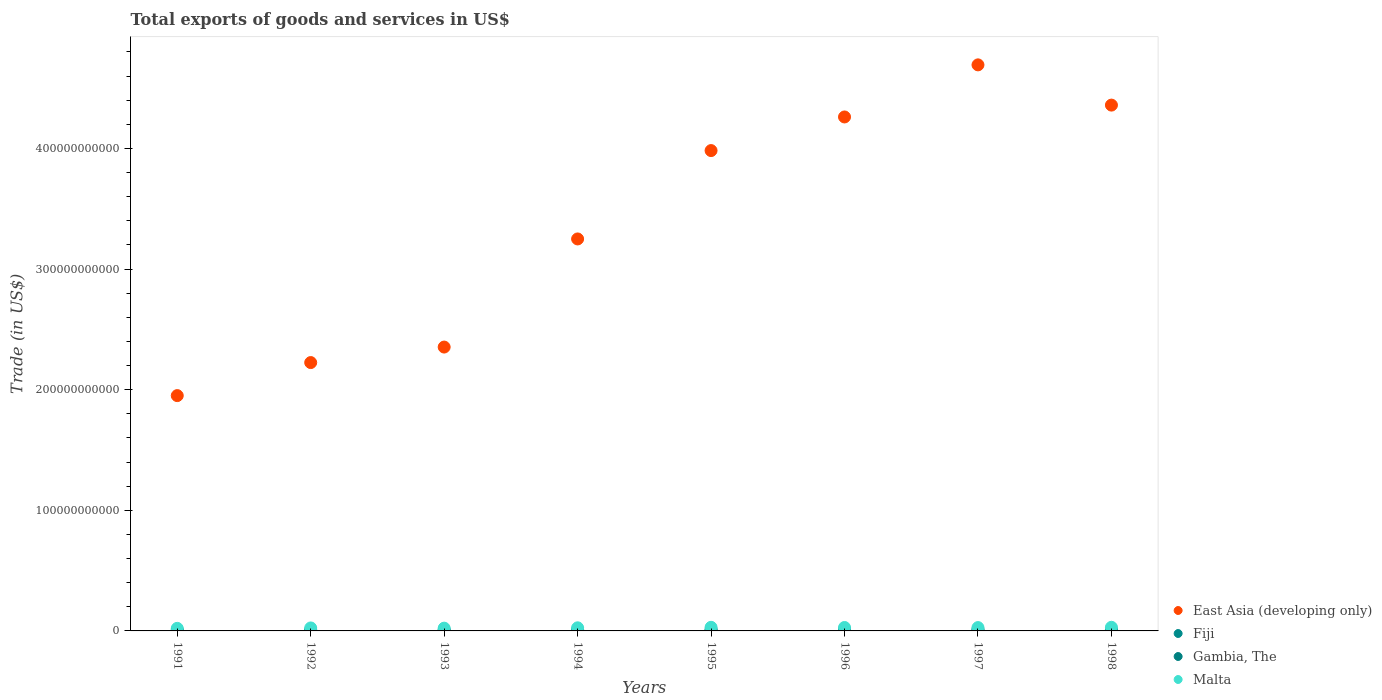How many different coloured dotlines are there?
Ensure brevity in your answer.  4. Is the number of dotlines equal to the number of legend labels?
Ensure brevity in your answer.  Yes. What is the total exports of goods and services in East Asia (developing only) in 1992?
Keep it short and to the point. 2.22e+11. Across all years, what is the maximum total exports of goods and services in Malta?
Offer a very short reply. 3.00e+09. Across all years, what is the minimum total exports of goods and services in Gambia, The?
Your answer should be very brief. 1.59e+08. In which year was the total exports of goods and services in East Asia (developing only) maximum?
Your answer should be compact. 1997. In which year was the total exports of goods and services in Fiji minimum?
Provide a succinct answer. 1991. What is the total total exports of goods and services in Fiji in the graph?
Your answer should be compact. 8.27e+09. What is the difference between the total exports of goods and services in East Asia (developing only) in 1994 and that in 1996?
Keep it short and to the point. -1.01e+11. What is the difference between the total exports of goods and services in Malta in 1998 and the total exports of goods and services in East Asia (developing only) in 1995?
Your answer should be compact. -3.95e+11. What is the average total exports of goods and services in Gambia, The per year?
Make the answer very short. 1.95e+08. In the year 1997, what is the difference between the total exports of goods and services in Fiji and total exports of goods and services in Gambia, The?
Ensure brevity in your answer.  1.09e+09. In how many years, is the total exports of goods and services in Fiji greater than 140000000000 US$?
Give a very brief answer. 0. What is the ratio of the total exports of goods and services in Malta in 1991 to that in 1995?
Give a very brief answer. 0.71. Is the difference between the total exports of goods and services in Fiji in 1993 and 1995 greater than the difference between the total exports of goods and services in Gambia, The in 1993 and 1995?
Your answer should be very brief. No. What is the difference between the highest and the second highest total exports of goods and services in Fiji?
Make the answer very short. 6.00e+07. What is the difference between the highest and the lowest total exports of goods and services in Gambia, The?
Your answer should be very brief. 6.00e+07. In how many years, is the total exports of goods and services in East Asia (developing only) greater than the average total exports of goods and services in East Asia (developing only) taken over all years?
Make the answer very short. 4. Is the sum of the total exports of goods and services in Gambia, The in 1993 and 1994 greater than the maximum total exports of goods and services in Fiji across all years?
Offer a terse response. No. Is it the case that in every year, the sum of the total exports of goods and services in Gambia, The and total exports of goods and services in Fiji  is greater than the sum of total exports of goods and services in East Asia (developing only) and total exports of goods and services in Malta?
Ensure brevity in your answer.  Yes. Is it the case that in every year, the sum of the total exports of goods and services in East Asia (developing only) and total exports of goods and services in Malta  is greater than the total exports of goods and services in Gambia, The?
Provide a succinct answer. Yes. Does the total exports of goods and services in East Asia (developing only) monotonically increase over the years?
Offer a very short reply. No. Is the total exports of goods and services in Gambia, The strictly less than the total exports of goods and services in Fiji over the years?
Offer a very short reply. Yes. How many dotlines are there?
Offer a very short reply. 4. What is the difference between two consecutive major ticks on the Y-axis?
Keep it short and to the point. 1.00e+11. Are the values on the major ticks of Y-axis written in scientific E-notation?
Keep it short and to the point. No. Does the graph contain any zero values?
Offer a terse response. No. Where does the legend appear in the graph?
Ensure brevity in your answer.  Bottom right. How many legend labels are there?
Offer a very short reply. 4. How are the legend labels stacked?
Offer a very short reply. Vertical. What is the title of the graph?
Your answer should be compact. Total exports of goods and services in US$. What is the label or title of the X-axis?
Provide a succinct answer. Years. What is the label or title of the Y-axis?
Ensure brevity in your answer.  Trade (in US$). What is the Trade (in US$) in East Asia (developing only) in 1991?
Your answer should be very brief. 1.95e+11. What is the Trade (in US$) in Fiji in 1991?
Ensure brevity in your answer.  7.93e+08. What is the Trade (in US$) in Gambia, The in 1991?
Keep it short and to the point. 2.03e+08. What is the Trade (in US$) of Malta in 1991?
Provide a short and direct response. 2.13e+09. What is the Trade (in US$) in East Asia (developing only) in 1992?
Provide a short and direct response. 2.22e+11. What is the Trade (in US$) in Fiji in 1992?
Your response must be concise. 7.95e+08. What is the Trade (in US$) of Gambia, The in 1992?
Your answer should be compact. 2.19e+08. What is the Trade (in US$) in Malta in 1992?
Provide a succinct answer. 2.47e+09. What is the Trade (in US$) in East Asia (developing only) in 1993?
Keep it short and to the point. 2.35e+11. What is the Trade (in US$) of Fiji in 1993?
Your answer should be very brief. 8.57e+08. What is the Trade (in US$) in Gambia, The in 1993?
Make the answer very short. 2.13e+08. What is the Trade (in US$) of Malta in 1993?
Your answer should be very brief. 2.30e+09. What is the Trade (in US$) in East Asia (developing only) in 1994?
Keep it short and to the point. 3.25e+11. What is the Trade (in US$) of Fiji in 1994?
Ensure brevity in your answer.  1.03e+09. What is the Trade (in US$) of Gambia, The in 1994?
Your response must be concise. 1.59e+08. What is the Trade (in US$) in Malta in 1994?
Offer a very short reply. 2.58e+09. What is the Trade (in US$) of East Asia (developing only) in 1995?
Your answer should be very brief. 3.98e+11. What is the Trade (in US$) in Fiji in 1995?
Give a very brief answer. 1.17e+09. What is the Trade (in US$) of Gambia, The in 1995?
Offer a terse response. 1.87e+08. What is the Trade (in US$) of Malta in 1995?
Your answer should be compact. 2.99e+09. What is the Trade (in US$) in East Asia (developing only) in 1996?
Provide a succinct answer. 4.26e+11. What is the Trade (in US$) of Fiji in 1996?
Your answer should be very brief. 1.34e+09. What is the Trade (in US$) of Gambia, The in 1996?
Ensure brevity in your answer.  1.85e+08. What is the Trade (in US$) in Malta in 1996?
Make the answer very short. 2.84e+09. What is the Trade (in US$) in East Asia (developing only) in 1997?
Your response must be concise. 4.69e+11. What is the Trade (in US$) in Fiji in 1997?
Give a very brief answer. 1.28e+09. What is the Trade (in US$) of Gambia, The in 1997?
Offer a very short reply. 1.84e+08. What is the Trade (in US$) of Malta in 1997?
Provide a short and direct response. 2.77e+09. What is the Trade (in US$) in East Asia (developing only) in 1998?
Ensure brevity in your answer.  4.36e+11. What is the Trade (in US$) in Fiji in 1998?
Your answer should be compact. 1.01e+09. What is the Trade (in US$) of Gambia, The in 1998?
Provide a short and direct response. 2.13e+08. What is the Trade (in US$) of Malta in 1998?
Offer a very short reply. 3.00e+09. Across all years, what is the maximum Trade (in US$) of East Asia (developing only)?
Your answer should be compact. 4.69e+11. Across all years, what is the maximum Trade (in US$) of Fiji?
Keep it short and to the point. 1.34e+09. Across all years, what is the maximum Trade (in US$) of Gambia, The?
Keep it short and to the point. 2.19e+08. Across all years, what is the maximum Trade (in US$) in Malta?
Make the answer very short. 3.00e+09. Across all years, what is the minimum Trade (in US$) of East Asia (developing only)?
Keep it short and to the point. 1.95e+11. Across all years, what is the minimum Trade (in US$) of Fiji?
Your answer should be very brief. 7.93e+08. Across all years, what is the minimum Trade (in US$) in Gambia, The?
Make the answer very short. 1.59e+08. Across all years, what is the minimum Trade (in US$) of Malta?
Your answer should be compact. 2.13e+09. What is the total Trade (in US$) in East Asia (developing only) in the graph?
Your answer should be very brief. 2.71e+12. What is the total Trade (in US$) in Fiji in the graph?
Your answer should be compact. 8.27e+09. What is the total Trade (in US$) in Gambia, The in the graph?
Your response must be concise. 1.56e+09. What is the total Trade (in US$) of Malta in the graph?
Offer a terse response. 2.11e+1. What is the difference between the Trade (in US$) of East Asia (developing only) in 1991 and that in 1992?
Make the answer very short. -2.74e+1. What is the difference between the Trade (in US$) in Fiji in 1991 and that in 1992?
Your answer should be very brief. -2.18e+06. What is the difference between the Trade (in US$) in Gambia, The in 1991 and that in 1992?
Offer a very short reply. -1.53e+07. What is the difference between the Trade (in US$) in Malta in 1991 and that in 1992?
Your answer should be compact. -3.43e+08. What is the difference between the Trade (in US$) in East Asia (developing only) in 1991 and that in 1993?
Ensure brevity in your answer.  -4.02e+1. What is the difference between the Trade (in US$) in Fiji in 1991 and that in 1993?
Keep it short and to the point. -6.35e+07. What is the difference between the Trade (in US$) of Gambia, The in 1991 and that in 1993?
Make the answer very short. -9.64e+06. What is the difference between the Trade (in US$) in Malta in 1991 and that in 1993?
Ensure brevity in your answer.  -1.70e+08. What is the difference between the Trade (in US$) in East Asia (developing only) in 1991 and that in 1994?
Your response must be concise. -1.30e+11. What is the difference between the Trade (in US$) of Fiji in 1991 and that in 1994?
Your response must be concise. -2.37e+08. What is the difference between the Trade (in US$) of Gambia, The in 1991 and that in 1994?
Keep it short and to the point. 4.47e+07. What is the difference between the Trade (in US$) in Malta in 1991 and that in 1994?
Offer a terse response. -4.50e+08. What is the difference between the Trade (in US$) in East Asia (developing only) in 1991 and that in 1995?
Your answer should be compact. -2.03e+11. What is the difference between the Trade (in US$) in Fiji in 1991 and that in 1995?
Provide a succinct answer. -3.75e+08. What is the difference between the Trade (in US$) in Gambia, The in 1991 and that in 1995?
Provide a succinct answer. 1.63e+07. What is the difference between the Trade (in US$) of Malta in 1991 and that in 1995?
Make the answer very short. -8.63e+08. What is the difference between the Trade (in US$) of East Asia (developing only) in 1991 and that in 1996?
Provide a short and direct response. -2.31e+11. What is the difference between the Trade (in US$) of Fiji in 1991 and that in 1996?
Offer a terse response. -5.45e+08. What is the difference between the Trade (in US$) of Gambia, The in 1991 and that in 1996?
Your answer should be very brief. 1.83e+07. What is the difference between the Trade (in US$) in Malta in 1991 and that in 1996?
Provide a succinct answer. -7.15e+08. What is the difference between the Trade (in US$) of East Asia (developing only) in 1991 and that in 1997?
Your answer should be very brief. -2.74e+11. What is the difference between the Trade (in US$) of Fiji in 1991 and that in 1997?
Keep it short and to the point. -4.85e+08. What is the difference between the Trade (in US$) of Gambia, The in 1991 and that in 1997?
Give a very brief answer. 1.89e+07. What is the difference between the Trade (in US$) of Malta in 1991 and that in 1997?
Keep it short and to the point. -6.44e+08. What is the difference between the Trade (in US$) of East Asia (developing only) in 1991 and that in 1998?
Your response must be concise. -2.41e+11. What is the difference between the Trade (in US$) in Fiji in 1991 and that in 1998?
Offer a terse response. -2.14e+08. What is the difference between the Trade (in US$) in Gambia, The in 1991 and that in 1998?
Make the answer very short. -9.42e+06. What is the difference between the Trade (in US$) of Malta in 1991 and that in 1998?
Ensure brevity in your answer.  -8.77e+08. What is the difference between the Trade (in US$) in East Asia (developing only) in 1992 and that in 1993?
Ensure brevity in your answer.  -1.29e+1. What is the difference between the Trade (in US$) of Fiji in 1992 and that in 1993?
Provide a short and direct response. -6.13e+07. What is the difference between the Trade (in US$) of Gambia, The in 1992 and that in 1993?
Ensure brevity in your answer.  5.65e+06. What is the difference between the Trade (in US$) of Malta in 1992 and that in 1993?
Your answer should be compact. 1.73e+08. What is the difference between the Trade (in US$) in East Asia (developing only) in 1992 and that in 1994?
Ensure brevity in your answer.  -1.02e+11. What is the difference between the Trade (in US$) in Fiji in 1992 and that in 1994?
Your answer should be compact. -2.35e+08. What is the difference between the Trade (in US$) of Gambia, The in 1992 and that in 1994?
Provide a succinct answer. 6.00e+07. What is the difference between the Trade (in US$) of Malta in 1992 and that in 1994?
Your answer should be compact. -1.07e+08. What is the difference between the Trade (in US$) of East Asia (developing only) in 1992 and that in 1995?
Your response must be concise. -1.76e+11. What is the difference between the Trade (in US$) of Fiji in 1992 and that in 1995?
Your answer should be very brief. -3.73e+08. What is the difference between the Trade (in US$) of Gambia, The in 1992 and that in 1995?
Keep it short and to the point. 3.16e+07. What is the difference between the Trade (in US$) of Malta in 1992 and that in 1995?
Keep it short and to the point. -5.20e+08. What is the difference between the Trade (in US$) in East Asia (developing only) in 1992 and that in 1996?
Ensure brevity in your answer.  -2.04e+11. What is the difference between the Trade (in US$) of Fiji in 1992 and that in 1996?
Provide a short and direct response. -5.43e+08. What is the difference between the Trade (in US$) in Gambia, The in 1992 and that in 1996?
Give a very brief answer. 3.36e+07. What is the difference between the Trade (in US$) of Malta in 1992 and that in 1996?
Give a very brief answer. -3.72e+08. What is the difference between the Trade (in US$) in East Asia (developing only) in 1992 and that in 1997?
Offer a very short reply. -2.47e+11. What is the difference between the Trade (in US$) in Fiji in 1992 and that in 1997?
Your answer should be very brief. -4.83e+08. What is the difference between the Trade (in US$) in Gambia, The in 1992 and that in 1997?
Offer a very short reply. 3.42e+07. What is the difference between the Trade (in US$) of Malta in 1992 and that in 1997?
Keep it short and to the point. -3.01e+08. What is the difference between the Trade (in US$) in East Asia (developing only) in 1992 and that in 1998?
Your response must be concise. -2.13e+11. What is the difference between the Trade (in US$) in Fiji in 1992 and that in 1998?
Provide a short and direct response. -2.12e+08. What is the difference between the Trade (in US$) of Gambia, The in 1992 and that in 1998?
Offer a terse response. 5.87e+06. What is the difference between the Trade (in US$) of Malta in 1992 and that in 1998?
Provide a short and direct response. -5.34e+08. What is the difference between the Trade (in US$) in East Asia (developing only) in 1993 and that in 1994?
Offer a very short reply. -8.96e+1. What is the difference between the Trade (in US$) of Fiji in 1993 and that in 1994?
Ensure brevity in your answer.  -1.73e+08. What is the difference between the Trade (in US$) in Gambia, The in 1993 and that in 1994?
Your answer should be very brief. 5.43e+07. What is the difference between the Trade (in US$) of Malta in 1993 and that in 1994?
Provide a succinct answer. -2.80e+08. What is the difference between the Trade (in US$) in East Asia (developing only) in 1993 and that in 1995?
Keep it short and to the point. -1.63e+11. What is the difference between the Trade (in US$) of Fiji in 1993 and that in 1995?
Provide a short and direct response. -3.12e+08. What is the difference between the Trade (in US$) of Gambia, The in 1993 and that in 1995?
Offer a very short reply. 2.60e+07. What is the difference between the Trade (in US$) in Malta in 1993 and that in 1995?
Your answer should be very brief. -6.93e+08. What is the difference between the Trade (in US$) in East Asia (developing only) in 1993 and that in 1996?
Provide a succinct answer. -1.91e+11. What is the difference between the Trade (in US$) in Fiji in 1993 and that in 1996?
Ensure brevity in your answer.  -4.82e+08. What is the difference between the Trade (in US$) in Gambia, The in 1993 and that in 1996?
Give a very brief answer. 2.80e+07. What is the difference between the Trade (in US$) of Malta in 1993 and that in 1996?
Offer a terse response. -5.45e+08. What is the difference between the Trade (in US$) of East Asia (developing only) in 1993 and that in 1997?
Your answer should be very brief. -2.34e+11. What is the difference between the Trade (in US$) of Fiji in 1993 and that in 1997?
Make the answer very short. -4.22e+08. What is the difference between the Trade (in US$) in Gambia, The in 1993 and that in 1997?
Offer a terse response. 2.86e+07. What is the difference between the Trade (in US$) of Malta in 1993 and that in 1997?
Your answer should be compact. -4.74e+08. What is the difference between the Trade (in US$) in East Asia (developing only) in 1993 and that in 1998?
Provide a succinct answer. -2.01e+11. What is the difference between the Trade (in US$) in Fiji in 1993 and that in 1998?
Offer a very short reply. -1.51e+08. What is the difference between the Trade (in US$) in Gambia, The in 1993 and that in 1998?
Give a very brief answer. 2.23e+05. What is the difference between the Trade (in US$) of Malta in 1993 and that in 1998?
Provide a succinct answer. -7.07e+08. What is the difference between the Trade (in US$) of East Asia (developing only) in 1994 and that in 1995?
Your answer should be compact. -7.33e+1. What is the difference between the Trade (in US$) of Fiji in 1994 and that in 1995?
Give a very brief answer. -1.38e+08. What is the difference between the Trade (in US$) in Gambia, The in 1994 and that in 1995?
Offer a very short reply. -2.83e+07. What is the difference between the Trade (in US$) of Malta in 1994 and that in 1995?
Your answer should be compact. -4.13e+08. What is the difference between the Trade (in US$) of East Asia (developing only) in 1994 and that in 1996?
Offer a very short reply. -1.01e+11. What is the difference between the Trade (in US$) of Fiji in 1994 and that in 1996?
Make the answer very short. -3.08e+08. What is the difference between the Trade (in US$) of Gambia, The in 1994 and that in 1996?
Provide a short and direct response. -2.64e+07. What is the difference between the Trade (in US$) of Malta in 1994 and that in 1996?
Your response must be concise. -2.65e+08. What is the difference between the Trade (in US$) in East Asia (developing only) in 1994 and that in 1997?
Your response must be concise. -1.44e+11. What is the difference between the Trade (in US$) in Fiji in 1994 and that in 1997?
Make the answer very short. -2.48e+08. What is the difference between the Trade (in US$) in Gambia, The in 1994 and that in 1997?
Make the answer very short. -2.57e+07. What is the difference between the Trade (in US$) of Malta in 1994 and that in 1997?
Ensure brevity in your answer.  -1.94e+08. What is the difference between the Trade (in US$) of East Asia (developing only) in 1994 and that in 1998?
Provide a short and direct response. -1.11e+11. What is the difference between the Trade (in US$) in Fiji in 1994 and that in 1998?
Make the answer very short. 2.24e+07. What is the difference between the Trade (in US$) in Gambia, The in 1994 and that in 1998?
Make the answer very short. -5.41e+07. What is the difference between the Trade (in US$) of Malta in 1994 and that in 1998?
Offer a very short reply. -4.27e+08. What is the difference between the Trade (in US$) in East Asia (developing only) in 1995 and that in 1996?
Give a very brief answer. -2.79e+1. What is the difference between the Trade (in US$) of Fiji in 1995 and that in 1996?
Provide a succinct answer. -1.70e+08. What is the difference between the Trade (in US$) in Gambia, The in 1995 and that in 1996?
Your answer should be very brief. 1.97e+06. What is the difference between the Trade (in US$) in Malta in 1995 and that in 1996?
Your answer should be very brief. 1.48e+08. What is the difference between the Trade (in US$) in East Asia (developing only) in 1995 and that in 1997?
Offer a terse response. -7.11e+1. What is the difference between the Trade (in US$) in Fiji in 1995 and that in 1997?
Offer a very short reply. -1.10e+08. What is the difference between the Trade (in US$) of Gambia, The in 1995 and that in 1997?
Your answer should be very brief. 2.59e+06. What is the difference between the Trade (in US$) in Malta in 1995 and that in 1997?
Make the answer very short. 2.19e+08. What is the difference between the Trade (in US$) in East Asia (developing only) in 1995 and that in 1998?
Keep it short and to the point. -3.77e+1. What is the difference between the Trade (in US$) of Fiji in 1995 and that in 1998?
Make the answer very short. 1.61e+08. What is the difference between the Trade (in US$) in Gambia, The in 1995 and that in 1998?
Your answer should be very brief. -2.58e+07. What is the difference between the Trade (in US$) of Malta in 1995 and that in 1998?
Your answer should be very brief. -1.41e+07. What is the difference between the Trade (in US$) of East Asia (developing only) in 1996 and that in 1997?
Make the answer very short. -4.32e+1. What is the difference between the Trade (in US$) of Fiji in 1996 and that in 1997?
Provide a short and direct response. 6.00e+07. What is the difference between the Trade (in US$) of Gambia, The in 1996 and that in 1997?
Keep it short and to the point. 6.14e+05. What is the difference between the Trade (in US$) in Malta in 1996 and that in 1997?
Make the answer very short. 7.13e+07. What is the difference between the Trade (in US$) in East Asia (developing only) in 1996 and that in 1998?
Keep it short and to the point. -9.82e+09. What is the difference between the Trade (in US$) of Fiji in 1996 and that in 1998?
Your answer should be compact. 3.31e+08. What is the difference between the Trade (in US$) of Gambia, The in 1996 and that in 1998?
Your answer should be compact. -2.77e+07. What is the difference between the Trade (in US$) of Malta in 1996 and that in 1998?
Your answer should be compact. -1.62e+08. What is the difference between the Trade (in US$) in East Asia (developing only) in 1997 and that in 1998?
Your answer should be compact. 3.34e+1. What is the difference between the Trade (in US$) in Fiji in 1997 and that in 1998?
Make the answer very short. 2.71e+08. What is the difference between the Trade (in US$) of Gambia, The in 1997 and that in 1998?
Provide a short and direct response. -2.83e+07. What is the difference between the Trade (in US$) of Malta in 1997 and that in 1998?
Offer a terse response. -2.33e+08. What is the difference between the Trade (in US$) in East Asia (developing only) in 1991 and the Trade (in US$) in Fiji in 1992?
Offer a very short reply. 1.94e+11. What is the difference between the Trade (in US$) of East Asia (developing only) in 1991 and the Trade (in US$) of Gambia, The in 1992?
Your response must be concise. 1.95e+11. What is the difference between the Trade (in US$) of East Asia (developing only) in 1991 and the Trade (in US$) of Malta in 1992?
Your answer should be very brief. 1.93e+11. What is the difference between the Trade (in US$) in Fiji in 1991 and the Trade (in US$) in Gambia, The in 1992?
Keep it short and to the point. 5.75e+08. What is the difference between the Trade (in US$) in Fiji in 1991 and the Trade (in US$) in Malta in 1992?
Keep it short and to the point. -1.68e+09. What is the difference between the Trade (in US$) in Gambia, The in 1991 and the Trade (in US$) in Malta in 1992?
Make the answer very short. -2.27e+09. What is the difference between the Trade (in US$) in East Asia (developing only) in 1991 and the Trade (in US$) in Fiji in 1993?
Make the answer very short. 1.94e+11. What is the difference between the Trade (in US$) of East Asia (developing only) in 1991 and the Trade (in US$) of Gambia, The in 1993?
Your answer should be compact. 1.95e+11. What is the difference between the Trade (in US$) in East Asia (developing only) in 1991 and the Trade (in US$) in Malta in 1993?
Your response must be concise. 1.93e+11. What is the difference between the Trade (in US$) in Fiji in 1991 and the Trade (in US$) in Gambia, The in 1993?
Your answer should be very brief. 5.80e+08. What is the difference between the Trade (in US$) in Fiji in 1991 and the Trade (in US$) in Malta in 1993?
Your response must be concise. -1.50e+09. What is the difference between the Trade (in US$) of Gambia, The in 1991 and the Trade (in US$) of Malta in 1993?
Make the answer very short. -2.09e+09. What is the difference between the Trade (in US$) of East Asia (developing only) in 1991 and the Trade (in US$) of Fiji in 1994?
Make the answer very short. 1.94e+11. What is the difference between the Trade (in US$) of East Asia (developing only) in 1991 and the Trade (in US$) of Gambia, The in 1994?
Make the answer very short. 1.95e+11. What is the difference between the Trade (in US$) in East Asia (developing only) in 1991 and the Trade (in US$) in Malta in 1994?
Ensure brevity in your answer.  1.92e+11. What is the difference between the Trade (in US$) in Fiji in 1991 and the Trade (in US$) in Gambia, The in 1994?
Your answer should be compact. 6.35e+08. What is the difference between the Trade (in US$) in Fiji in 1991 and the Trade (in US$) in Malta in 1994?
Provide a succinct answer. -1.78e+09. What is the difference between the Trade (in US$) in Gambia, The in 1991 and the Trade (in US$) in Malta in 1994?
Provide a short and direct response. -2.37e+09. What is the difference between the Trade (in US$) in East Asia (developing only) in 1991 and the Trade (in US$) in Fiji in 1995?
Make the answer very short. 1.94e+11. What is the difference between the Trade (in US$) of East Asia (developing only) in 1991 and the Trade (in US$) of Gambia, The in 1995?
Provide a succinct answer. 1.95e+11. What is the difference between the Trade (in US$) of East Asia (developing only) in 1991 and the Trade (in US$) of Malta in 1995?
Your answer should be very brief. 1.92e+11. What is the difference between the Trade (in US$) in Fiji in 1991 and the Trade (in US$) in Gambia, The in 1995?
Keep it short and to the point. 6.06e+08. What is the difference between the Trade (in US$) of Fiji in 1991 and the Trade (in US$) of Malta in 1995?
Make the answer very short. -2.20e+09. What is the difference between the Trade (in US$) in Gambia, The in 1991 and the Trade (in US$) in Malta in 1995?
Provide a short and direct response. -2.79e+09. What is the difference between the Trade (in US$) in East Asia (developing only) in 1991 and the Trade (in US$) in Fiji in 1996?
Offer a very short reply. 1.94e+11. What is the difference between the Trade (in US$) in East Asia (developing only) in 1991 and the Trade (in US$) in Gambia, The in 1996?
Make the answer very short. 1.95e+11. What is the difference between the Trade (in US$) of East Asia (developing only) in 1991 and the Trade (in US$) of Malta in 1996?
Provide a short and direct response. 1.92e+11. What is the difference between the Trade (in US$) of Fiji in 1991 and the Trade (in US$) of Gambia, The in 1996?
Offer a very short reply. 6.08e+08. What is the difference between the Trade (in US$) of Fiji in 1991 and the Trade (in US$) of Malta in 1996?
Offer a terse response. -2.05e+09. What is the difference between the Trade (in US$) of Gambia, The in 1991 and the Trade (in US$) of Malta in 1996?
Offer a terse response. -2.64e+09. What is the difference between the Trade (in US$) in East Asia (developing only) in 1991 and the Trade (in US$) in Fiji in 1997?
Ensure brevity in your answer.  1.94e+11. What is the difference between the Trade (in US$) in East Asia (developing only) in 1991 and the Trade (in US$) in Gambia, The in 1997?
Your answer should be compact. 1.95e+11. What is the difference between the Trade (in US$) in East Asia (developing only) in 1991 and the Trade (in US$) in Malta in 1997?
Offer a terse response. 1.92e+11. What is the difference between the Trade (in US$) in Fiji in 1991 and the Trade (in US$) in Gambia, The in 1997?
Provide a short and direct response. 6.09e+08. What is the difference between the Trade (in US$) in Fiji in 1991 and the Trade (in US$) in Malta in 1997?
Offer a very short reply. -1.98e+09. What is the difference between the Trade (in US$) in Gambia, The in 1991 and the Trade (in US$) in Malta in 1997?
Offer a very short reply. -2.57e+09. What is the difference between the Trade (in US$) of East Asia (developing only) in 1991 and the Trade (in US$) of Fiji in 1998?
Provide a short and direct response. 1.94e+11. What is the difference between the Trade (in US$) in East Asia (developing only) in 1991 and the Trade (in US$) in Gambia, The in 1998?
Offer a very short reply. 1.95e+11. What is the difference between the Trade (in US$) of East Asia (developing only) in 1991 and the Trade (in US$) of Malta in 1998?
Your answer should be compact. 1.92e+11. What is the difference between the Trade (in US$) in Fiji in 1991 and the Trade (in US$) in Gambia, The in 1998?
Ensure brevity in your answer.  5.80e+08. What is the difference between the Trade (in US$) of Fiji in 1991 and the Trade (in US$) of Malta in 1998?
Give a very brief answer. -2.21e+09. What is the difference between the Trade (in US$) of Gambia, The in 1991 and the Trade (in US$) of Malta in 1998?
Offer a terse response. -2.80e+09. What is the difference between the Trade (in US$) of East Asia (developing only) in 1992 and the Trade (in US$) of Fiji in 1993?
Your answer should be compact. 2.22e+11. What is the difference between the Trade (in US$) of East Asia (developing only) in 1992 and the Trade (in US$) of Gambia, The in 1993?
Provide a short and direct response. 2.22e+11. What is the difference between the Trade (in US$) in East Asia (developing only) in 1992 and the Trade (in US$) in Malta in 1993?
Make the answer very short. 2.20e+11. What is the difference between the Trade (in US$) in Fiji in 1992 and the Trade (in US$) in Gambia, The in 1993?
Offer a very short reply. 5.82e+08. What is the difference between the Trade (in US$) of Fiji in 1992 and the Trade (in US$) of Malta in 1993?
Give a very brief answer. -1.50e+09. What is the difference between the Trade (in US$) in Gambia, The in 1992 and the Trade (in US$) in Malta in 1993?
Ensure brevity in your answer.  -2.08e+09. What is the difference between the Trade (in US$) of East Asia (developing only) in 1992 and the Trade (in US$) of Fiji in 1994?
Give a very brief answer. 2.21e+11. What is the difference between the Trade (in US$) of East Asia (developing only) in 1992 and the Trade (in US$) of Gambia, The in 1994?
Offer a very short reply. 2.22e+11. What is the difference between the Trade (in US$) in East Asia (developing only) in 1992 and the Trade (in US$) in Malta in 1994?
Provide a succinct answer. 2.20e+11. What is the difference between the Trade (in US$) of Fiji in 1992 and the Trade (in US$) of Gambia, The in 1994?
Provide a short and direct response. 6.37e+08. What is the difference between the Trade (in US$) of Fiji in 1992 and the Trade (in US$) of Malta in 1994?
Your answer should be very brief. -1.78e+09. What is the difference between the Trade (in US$) in Gambia, The in 1992 and the Trade (in US$) in Malta in 1994?
Your answer should be compact. -2.36e+09. What is the difference between the Trade (in US$) of East Asia (developing only) in 1992 and the Trade (in US$) of Fiji in 1995?
Offer a very short reply. 2.21e+11. What is the difference between the Trade (in US$) in East Asia (developing only) in 1992 and the Trade (in US$) in Gambia, The in 1995?
Make the answer very short. 2.22e+11. What is the difference between the Trade (in US$) in East Asia (developing only) in 1992 and the Trade (in US$) in Malta in 1995?
Provide a short and direct response. 2.19e+11. What is the difference between the Trade (in US$) of Fiji in 1992 and the Trade (in US$) of Gambia, The in 1995?
Your answer should be compact. 6.08e+08. What is the difference between the Trade (in US$) of Fiji in 1992 and the Trade (in US$) of Malta in 1995?
Ensure brevity in your answer.  -2.20e+09. What is the difference between the Trade (in US$) in Gambia, The in 1992 and the Trade (in US$) in Malta in 1995?
Your answer should be very brief. -2.77e+09. What is the difference between the Trade (in US$) in East Asia (developing only) in 1992 and the Trade (in US$) in Fiji in 1996?
Offer a very short reply. 2.21e+11. What is the difference between the Trade (in US$) in East Asia (developing only) in 1992 and the Trade (in US$) in Gambia, The in 1996?
Your answer should be compact. 2.22e+11. What is the difference between the Trade (in US$) in East Asia (developing only) in 1992 and the Trade (in US$) in Malta in 1996?
Provide a succinct answer. 2.20e+11. What is the difference between the Trade (in US$) in Fiji in 1992 and the Trade (in US$) in Gambia, The in 1996?
Provide a succinct answer. 6.10e+08. What is the difference between the Trade (in US$) in Fiji in 1992 and the Trade (in US$) in Malta in 1996?
Provide a succinct answer. -2.05e+09. What is the difference between the Trade (in US$) in Gambia, The in 1992 and the Trade (in US$) in Malta in 1996?
Provide a short and direct response. -2.62e+09. What is the difference between the Trade (in US$) in East Asia (developing only) in 1992 and the Trade (in US$) in Fiji in 1997?
Offer a very short reply. 2.21e+11. What is the difference between the Trade (in US$) of East Asia (developing only) in 1992 and the Trade (in US$) of Gambia, The in 1997?
Offer a terse response. 2.22e+11. What is the difference between the Trade (in US$) in East Asia (developing only) in 1992 and the Trade (in US$) in Malta in 1997?
Provide a short and direct response. 2.20e+11. What is the difference between the Trade (in US$) in Fiji in 1992 and the Trade (in US$) in Gambia, The in 1997?
Ensure brevity in your answer.  6.11e+08. What is the difference between the Trade (in US$) of Fiji in 1992 and the Trade (in US$) of Malta in 1997?
Ensure brevity in your answer.  -1.98e+09. What is the difference between the Trade (in US$) in Gambia, The in 1992 and the Trade (in US$) in Malta in 1997?
Your answer should be very brief. -2.55e+09. What is the difference between the Trade (in US$) in East Asia (developing only) in 1992 and the Trade (in US$) in Fiji in 1998?
Ensure brevity in your answer.  2.21e+11. What is the difference between the Trade (in US$) in East Asia (developing only) in 1992 and the Trade (in US$) in Gambia, The in 1998?
Your response must be concise. 2.22e+11. What is the difference between the Trade (in US$) in East Asia (developing only) in 1992 and the Trade (in US$) in Malta in 1998?
Offer a terse response. 2.19e+11. What is the difference between the Trade (in US$) of Fiji in 1992 and the Trade (in US$) of Gambia, The in 1998?
Your answer should be very brief. 5.83e+08. What is the difference between the Trade (in US$) of Fiji in 1992 and the Trade (in US$) of Malta in 1998?
Make the answer very short. -2.21e+09. What is the difference between the Trade (in US$) in Gambia, The in 1992 and the Trade (in US$) in Malta in 1998?
Offer a very short reply. -2.79e+09. What is the difference between the Trade (in US$) of East Asia (developing only) in 1993 and the Trade (in US$) of Fiji in 1994?
Offer a very short reply. 2.34e+11. What is the difference between the Trade (in US$) in East Asia (developing only) in 1993 and the Trade (in US$) in Gambia, The in 1994?
Your response must be concise. 2.35e+11. What is the difference between the Trade (in US$) of East Asia (developing only) in 1993 and the Trade (in US$) of Malta in 1994?
Your answer should be compact. 2.33e+11. What is the difference between the Trade (in US$) of Fiji in 1993 and the Trade (in US$) of Gambia, The in 1994?
Provide a succinct answer. 6.98e+08. What is the difference between the Trade (in US$) of Fiji in 1993 and the Trade (in US$) of Malta in 1994?
Offer a terse response. -1.72e+09. What is the difference between the Trade (in US$) of Gambia, The in 1993 and the Trade (in US$) of Malta in 1994?
Your answer should be very brief. -2.36e+09. What is the difference between the Trade (in US$) in East Asia (developing only) in 1993 and the Trade (in US$) in Fiji in 1995?
Ensure brevity in your answer.  2.34e+11. What is the difference between the Trade (in US$) in East Asia (developing only) in 1993 and the Trade (in US$) in Gambia, The in 1995?
Provide a succinct answer. 2.35e+11. What is the difference between the Trade (in US$) of East Asia (developing only) in 1993 and the Trade (in US$) of Malta in 1995?
Give a very brief answer. 2.32e+11. What is the difference between the Trade (in US$) in Fiji in 1993 and the Trade (in US$) in Gambia, The in 1995?
Your answer should be very brief. 6.70e+08. What is the difference between the Trade (in US$) in Fiji in 1993 and the Trade (in US$) in Malta in 1995?
Offer a terse response. -2.13e+09. What is the difference between the Trade (in US$) in Gambia, The in 1993 and the Trade (in US$) in Malta in 1995?
Keep it short and to the point. -2.78e+09. What is the difference between the Trade (in US$) of East Asia (developing only) in 1993 and the Trade (in US$) of Fiji in 1996?
Keep it short and to the point. 2.34e+11. What is the difference between the Trade (in US$) of East Asia (developing only) in 1993 and the Trade (in US$) of Gambia, The in 1996?
Keep it short and to the point. 2.35e+11. What is the difference between the Trade (in US$) in East Asia (developing only) in 1993 and the Trade (in US$) in Malta in 1996?
Your answer should be very brief. 2.32e+11. What is the difference between the Trade (in US$) in Fiji in 1993 and the Trade (in US$) in Gambia, The in 1996?
Your answer should be compact. 6.72e+08. What is the difference between the Trade (in US$) in Fiji in 1993 and the Trade (in US$) in Malta in 1996?
Offer a terse response. -1.99e+09. What is the difference between the Trade (in US$) of Gambia, The in 1993 and the Trade (in US$) of Malta in 1996?
Keep it short and to the point. -2.63e+09. What is the difference between the Trade (in US$) in East Asia (developing only) in 1993 and the Trade (in US$) in Fiji in 1997?
Provide a succinct answer. 2.34e+11. What is the difference between the Trade (in US$) in East Asia (developing only) in 1993 and the Trade (in US$) in Gambia, The in 1997?
Give a very brief answer. 2.35e+11. What is the difference between the Trade (in US$) in East Asia (developing only) in 1993 and the Trade (in US$) in Malta in 1997?
Provide a succinct answer. 2.33e+11. What is the difference between the Trade (in US$) in Fiji in 1993 and the Trade (in US$) in Gambia, The in 1997?
Your answer should be compact. 6.72e+08. What is the difference between the Trade (in US$) of Fiji in 1993 and the Trade (in US$) of Malta in 1997?
Offer a very short reply. -1.91e+09. What is the difference between the Trade (in US$) in Gambia, The in 1993 and the Trade (in US$) in Malta in 1997?
Your response must be concise. -2.56e+09. What is the difference between the Trade (in US$) in East Asia (developing only) in 1993 and the Trade (in US$) in Fiji in 1998?
Your answer should be compact. 2.34e+11. What is the difference between the Trade (in US$) of East Asia (developing only) in 1993 and the Trade (in US$) of Gambia, The in 1998?
Provide a short and direct response. 2.35e+11. What is the difference between the Trade (in US$) of East Asia (developing only) in 1993 and the Trade (in US$) of Malta in 1998?
Provide a short and direct response. 2.32e+11. What is the difference between the Trade (in US$) of Fiji in 1993 and the Trade (in US$) of Gambia, The in 1998?
Offer a very short reply. 6.44e+08. What is the difference between the Trade (in US$) in Fiji in 1993 and the Trade (in US$) in Malta in 1998?
Ensure brevity in your answer.  -2.15e+09. What is the difference between the Trade (in US$) in Gambia, The in 1993 and the Trade (in US$) in Malta in 1998?
Your response must be concise. -2.79e+09. What is the difference between the Trade (in US$) of East Asia (developing only) in 1994 and the Trade (in US$) of Fiji in 1995?
Offer a terse response. 3.24e+11. What is the difference between the Trade (in US$) of East Asia (developing only) in 1994 and the Trade (in US$) of Gambia, The in 1995?
Keep it short and to the point. 3.25e+11. What is the difference between the Trade (in US$) in East Asia (developing only) in 1994 and the Trade (in US$) in Malta in 1995?
Offer a very short reply. 3.22e+11. What is the difference between the Trade (in US$) in Fiji in 1994 and the Trade (in US$) in Gambia, The in 1995?
Make the answer very short. 8.43e+08. What is the difference between the Trade (in US$) of Fiji in 1994 and the Trade (in US$) of Malta in 1995?
Provide a short and direct response. -1.96e+09. What is the difference between the Trade (in US$) in Gambia, The in 1994 and the Trade (in US$) in Malta in 1995?
Make the answer very short. -2.83e+09. What is the difference between the Trade (in US$) in East Asia (developing only) in 1994 and the Trade (in US$) in Fiji in 1996?
Make the answer very short. 3.24e+11. What is the difference between the Trade (in US$) of East Asia (developing only) in 1994 and the Trade (in US$) of Gambia, The in 1996?
Your response must be concise. 3.25e+11. What is the difference between the Trade (in US$) in East Asia (developing only) in 1994 and the Trade (in US$) in Malta in 1996?
Provide a short and direct response. 3.22e+11. What is the difference between the Trade (in US$) in Fiji in 1994 and the Trade (in US$) in Gambia, The in 1996?
Provide a short and direct response. 8.45e+08. What is the difference between the Trade (in US$) of Fiji in 1994 and the Trade (in US$) of Malta in 1996?
Provide a succinct answer. -1.81e+09. What is the difference between the Trade (in US$) in Gambia, The in 1994 and the Trade (in US$) in Malta in 1996?
Provide a succinct answer. -2.68e+09. What is the difference between the Trade (in US$) of East Asia (developing only) in 1994 and the Trade (in US$) of Fiji in 1997?
Your answer should be very brief. 3.24e+11. What is the difference between the Trade (in US$) in East Asia (developing only) in 1994 and the Trade (in US$) in Gambia, The in 1997?
Provide a short and direct response. 3.25e+11. What is the difference between the Trade (in US$) of East Asia (developing only) in 1994 and the Trade (in US$) of Malta in 1997?
Offer a terse response. 3.22e+11. What is the difference between the Trade (in US$) in Fiji in 1994 and the Trade (in US$) in Gambia, The in 1997?
Keep it short and to the point. 8.46e+08. What is the difference between the Trade (in US$) of Fiji in 1994 and the Trade (in US$) of Malta in 1997?
Offer a very short reply. -1.74e+09. What is the difference between the Trade (in US$) of Gambia, The in 1994 and the Trade (in US$) of Malta in 1997?
Provide a succinct answer. -2.61e+09. What is the difference between the Trade (in US$) in East Asia (developing only) in 1994 and the Trade (in US$) in Fiji in 1998?
Give a very brief answer. 3.24e+11. What is the difference between the Trade (in US$) in East Asia (developing only) in 1994 and the Trade (in US$) in Gambia, The in 1998?
Provide a succinct answer. 3.25e+11. What is the difference between the Trade (in US$) in East Asia (developing only) in 1994 and the Trade (in US$) in Malta in 1998?
Your answer should be compact. 3.22e+11. What is the difference between the Trade (in US$) in Fiji in 1994 and the Trade (in US$) in Gambia, The in 1998?
Your response must be concise. 8.17e+08. What is the difference between the Trade (in US$) in Fiji in 1994 and the Trade (in US$) in Malta in 1998?
Give a very brief answer. -1.98e+09. What is the difference between the Trade (in US$) of Gambia, The in 1994 and the Trade (in US$) of Malta in 1998?
Ensure brevity in your answer.  -2.85e+09. What is the difference between the Trade (in US$) in East Asia (developing only) in 1995 and the Trade (in US$) in Fiji in 1996?
Your response must be concise. 3.97e+11. What is the difference between the Trade (in US$) of East Asia (developing only) in 1995 and the Trade (in US$) of Gambia, The in 1996?
Offer a terse response. 3.98e+11. What is the difference between the Trade (in US$) of East Asia (developing only) in 1995 and the Trade (in US$) of Malta in 1996?
Offer a very short reply. 3.95e+11. What is the difference between the Trade (in US$) of Fiji in 1995 and the Trade (in US$) of Gambia, The in 1996?
Your answer should be very brief. 9.83e+08. What is the difference between the Trade (in US$) in Fiji in 1995 and the Trade (in US$) in Malta in 1996?
Make the answer very short. -1.67e+09. What is the difference between the Trade (in US$) in Gambia, The in 1995 and the Trade (in US$) in Malta in 1996?
Keep it short and to the point. -2.66e+09. What is the difference between the Trade (in US$) of East Asia (developing only) in 1995 and the Trade (in US$) of Fiji in 1997?
Provide a short and direct response. 3.97e+11. What is the difference between the Trade (in US$) in East Asia (developing only) in 1995 and the Trade (in US$) in Gambia, The in 1997?
Ensure brevity in your answer.  3.98e+11. What is the difference between the Trade (in US$) in East Asia (developing only) in 1995 and the Trade (in US$) in Malta in 1997?
Offer a terse response. 3.95e+11. What is the difference between the Trade (in US$) in Fiji in 1995 and the Trade (in US$) in Gambia, The in 1997?
Offer a very short reply. 9.84e+08. What is the difference between the Trade (in US$) of Fiji in 1995 and the Trade (in US$) of Malta in 1997?
Provide a short and direct response. -1.60e+09. What is the difference between the Trade (in US$) of Gambia, The in 1995 and the Trade (in US$) of Malta in 1997?
Your response must be concise. -2.58e+09. What is the difference between the Trade (in US$) in East Asia (developing only) in 1995 and the Trade (in US$) in Fiji in 1998?
Provide a succinct answer. 3.97e+11. What is the difference between the Trade (in US$) in East Asia (developing only) in 1995 and the Trade (in US$) in Gambia, The in 1998?
Give a very brief answer. 3.98e+11. What is the difference between the Trade (in US$) of East Asia (developing only) in 1995 and the Trade (in US$) of Malta in 1998?
Offer a very short reply. 3.95e+11. What is the difference between the Trade (in US$) in Fiji in 1995 and the Trade (in US$) in Gambia, The in 1998?
Ensure brevity in your answer.  9.56e+08. What is the difference between the Trade (in US$) in Fiji in 1995 and the Trade (in US$) in Malta in 1998?
Ensure brevity in your answer.  -1.84e+09. What is the difference between the Trade (in US$) of Gambia, The in 1995 and the Trade (in US$) of Malta in 1998?
Your answer should be compact. -2.82e+09. What is the difference between the Trade (in US$) in East Asia (developing only) in 1996 and the Trade (in US$) in Fiji in 1997?
Your response must be concise. 4.25e+11. What is the difference between the Trade (in US$) of East Asia (developing only) in 1996 and the Trade (in US$) of Gambia, The in 1997?
Offer a very short reply. 4.26e+11. What is the difference between the Trade (in US$) of East Asia (developing only) in 1996 and the Trade (in US$) of Malta in 1997?
Provide a succinct answer. 4.23e+11. What is the difference between the Trade (in US$) in Fiji in 1996 and the Trade (in US$) in Gambia, The in 1997?
Your response must be concise. 1.15e+09. What is the difference between the Trade (in US$) in Fiji in 1996 and the Trade (in US$) in Malta in 1997?
Provide a short and direct response. -1.43e+09. What is the difference between the Trade (in US$) of Gambia, The in 1996 and the Trade (in US$) of Malta in 1997?
Make the answer very short. -2.59e+09. What is the difference between the Trade (in US$) in East Asia (developing only) in 1996 and the Trade (in US$) in Fiji in 1998?
Your answer should be compact. 4.25e+11. What is the difference between the Trade (in US$) in East Asia (developing only) in 1996 and the Trade (in US$) in Gambia, The in 1998?
Offer a terse response. 4.26e+11. What is the difference between the Trade (in US$) of East Asia (developing only) in 1996 and the Trade (in US$) of Malta in 1998?
Your answer should be very brief. 4.23e+11. What is the difference between the Trade (in US$) in Fiji in 1996 and the Trade (in US$) in Gambia, The in 1998?
Make the answer very short. 1.13e+09. What is the difference between the Trade (in US$) in Fiji in 1996 and the Trade (in US$) in Malta in 1998?
Make the answer very short. -1.67e+09. What is the difference between the Trade (in US$) in Gambia, The in 1996 and the Trade (in US$) in Malta in 1998?
Your answer should be very brief. -2.82e+09. What is the difference between the Trade (in US$) of East Asia (developing only) in 1997 and the Trade (in US$) of Fiji in 1998?
Your answer should be compact. 4.68e+11. What is the difference between the Trade (in US$) in East Asia (developing only) in 1997 and the Trade (in US$) in Gambia, The in 1998?
Give a very brief answer. 4.69e+11. What is the difference between the Trade (in US$) of East Asia (developing only) in 1997 and the Trade (in US$) of Malta in 1998?
Your response must be concise. 4.66e+11. What is the difference between the Trade (in US$) in Fiji in 1997 and the Trade (in US$) in Gambia, The in 1998?
Provide a short and direct response. 1.07e+09. What is the difference between the Trade (in US$) of Fiji in 1997 and the Trade (in US$) of Malta in 1998?
Your answer should be very brief. -1.73e+09. What is the difference between the Trade (in US$) of Gambia, The in 1997 and the Trade (in US$) of Malta in 1998?
Your answer should be compact. -2.82e+09. What is the average Trade (in US$) of East Asia (developing only) per year?
Your answer should be compact. 3.38e+11. What is the average Trade (in US$) of Fiji per year?
Make the answer very short. 1.03e+09. What is the average Trade (in US$) of Gambia, The per year?
Provide a short and direct response. 1.95e+08. What is the average Trade (in US$) in Malta per year?
Provide a short and direct response. 2.64e+09. In the year 1991, what is the difference between the Trade (in US$) of East Asia (developing only) and Trade (in US$) of Fiji?
Keep it short and to the point. 1.94e+11. In the year 1991, what is the difference between the Trade (in US$) in East Asia (developing only) and Trade (in US$) in Gambia, The?
Keep it short and to the point. 1.95e+11. In the year 1991, what is the difference between the Trade (in US$) of East Asia (developing only) and Trade (in US$) of Malta?
Your answer should be compact. 1.93e+11. In the year 1991, what is the difference between the Trade (in US$) of Fiji and Trade (in US$) of Gambia, The?
Keep it short and to the point. 5.90e+08. In the year 1991, what is the difference between the Trade (in US$) of Fiji and Trade (in US$) of Malta?
Offer a very short reply. -1.33e+09. In the year 1991, what is the difference between the Trade (in US$) of Gambia, The and Trade (in US$) of Malta?
Your answer should be very brief. -1.92e+09. In the year 1992, what is the difference between the Trade (in US$) in East Asia (developing only) and Trade (in US$) in Fiji?
Keep it short and to the point. 2.22e+11. In the year 1992, what is the difference between the Trade (in US$) of East Asia (developing only) and Trade (in US$) of Gambia, The?
Provide a short and direct response. 2.22e+11. In the year 1992, what is the difference between the Trade (in US$) in East Asia (developing only) and Trade (in US$) in Malta?
Provide a short and direct response. 2.20e+11. In the year 1992, what is the difference between the Trade (in US$) of Fiji and Trade (in US$) of Gambia, The?
Ensure brevity in your answer.  5.77e+08. In the year 1992, what is the difference between the Trade (in US$) in Fiji and Trade (in US$) in Malta?
Provide a short and direct response. -1.68e+09. In the year 1992, what is the difference between the Trade (in US$) of Gambia, The and Trade (in US$) of Malta?
Provide a succinct answer. -2.25e+09. In the year 1993, what is the difference between the Trade (in US$) in East Asia (developing only) and Trade (in US$) in Fiji?
Your answer should be very brief. 2.34e+11. In the year 1993, what is the difference between the Trade (in US$) of East Asia (developing only) and Trade (in US$) of Gambia, The?
Make the answer very short. 2.35e+11. In the year 1993, what is the difference between the Trade (in US$) of East Asia (developing only) and Trade (in US$) of Malta?
Keep it short and to the point. 2.33e+11. In the year 1993, what is the difference between the Trade (in US$) in Fiji and Trade (in US$) in Gambia, The?
Provide a succinct answer. 6.44e+08. In the year 1993, what is the difference between the Trade (in US$) of Fiji and Trade (in US$) of Malta?
Offer a terse response. -1.44e+09. In the year 1993, what is the difference between the Trade (in US$) in Gambia, The and Trade (in US$) in Malta?
Keep it short and to the point. -2.08e+09. In the year 1994, what is the difference between the Trade (in US$) of East Asia (developing only) and Trade (in US$) of Fiji?
Offer a terse response. 3.24e+11. In the year 1994, what is the difference between the Trade (in US$) of East Asia (developing only) and Trade (in US$) of Gambia, The?
Provide a succinct answer. 3.25e+11. In the year 1994, what is the difference between the Trade (in US$) of East Asia (developing only) and Trade (in US$) of Malta?
Make the answer very short. 3.22e+11. In the year 1994, what is the difference between the Trade (in US$) in Fiji and Trade (in US$) in Gambia, The?
Your response must be concise. 8.71e+08. In the year 1994, what is the difference between the Trade (in US$) of Fiji and Trade (in US$) of Malta?
Keep it short and to the point. -1.55e+09. In the year 1994, what is the difference between the Trade (in US$) in Gambia, The and Trade (in US$) in Malta?
Give a very brief answer. -2.42e+09. In the year 1995, what is the difference between the Trade (in US$) in East Asia (developing only) and Trade (in US$) in Fiji?
Your response must be concise. 3.97e+11. In the year 1995, what is the difference between the Trade (in US$) of East Asia (developing only) and Trade (in US$) of Gambia, The?
Provide a succinct answer. 3.98e+11. In the year 1995, what is the difference between the Trade (in US$) in East Asia (developing only) and Trade (in US$) in Malta?
Provide a short and direct response. 3.95e+11. In the year 1995, what is the difference between the Trade (in US$) of Fiji and Trade (in US$) of Gambia, The?
Your answer should be compact. 9.81e+08. In the year 1995, what is the difference between the Trade (in US$) of Fiji and Trade (in US$) of Malta?
Offer a very short reply. -1.82e+09. In the year 1995, what is the difference between the Trade (in US$) of Gambia, The and Trade (in US$) of Malta?
Offer a terse response. -2.80e+09. In the year 1996, what is the difference between the Trade (in US$) in East Asia (developing only) and Trade (in US$) in Fiji?
Ensure brevity in your answer.  4.25e+11. In the year 1996, what is the difference between the Trade (in US$) of East Asia (developing only) and Trade (in US$) of Gambia, The?
Keep it short and to the point. 4.26e+11. In the year 1996, what is the difference between the Trade (in US$) in East Asia (developing only) and Trade (in US$) in Malta?
Your answer should be compact. 4.23e+11. In the year 1996, what is the difference between the Trade (in US$) in Fiji and Trade (in US$) in Gambia, The?
Provide a short and direct response. 1.15e+09. In the year 1996, what is the difference between the Trade (in US$) of Fiji and Trade (in US$) of Malta?
Offer a very short reply. -1.50e+09. In the year 1996, what is the difference between the Trade (in US$) in Gambia, The and Trade (in US$) in Malta?
Make the answer very short. -2.66e+09. In the year 1997, what is the difference between the Trade (in US$) in East Asia (developing only) and Trade (in US$) in Fiji?
Offer a terse response. 4.68e+11. In the year 1997, what is the difference between the Trade (in US$) of East Asia (developing only) and Trade (in US$) of Gambia, The?
Keep it short and to the point. 4.69e+11. In the year 1997, what is the difference between the Trade (in US$) of East Asia (developing only) and Trade (in US$) of Malta?
Your response must be concise. 4.66e+11. In the year 1997, what is the difference between the Trade (in US$) in Fiji and Trade (in US$) in Gambia, The?
Offer a terse response. 1.09e+09. In the year 1997, what is the difference between the Trade (in US$) of Fiji and Trade (in US$) of Malta?
Ensure brevity in your answer.  -1.49e+09. In the year 1997, what is the difference between the Trade (in US$) of Gambia, The and Trade (in US$) of Malta?
Provide a succinct answer. -2.59e+09. In the year 1998, what is the difference between the Trade (in US$) in East Asia (developing only) and Trade (in US$) in Fiji?
Your answer should be very brief. 4.35e+11. In the year 1998, what is the difference between the Trade (in US$) of East Asia (developing only) and Trade (in US$) of Gambia, The?
Provide a succinct answer. 4.36e+11. In the year 1998, what is the difference between the Trade (in US$) in East Asia (developing only) and Trade (in US$) in Malta?
Give a very brief answer. 4.33e+11. In the year 1998, what is the difference between the Trade (in US$) of Fiji and Trade (in US$) of Gambia, The?
Provide a short and direct response. 7.95e+08. In the year 1998, what is the difference between the Trade (in US$) in Fiji and Trade (in US$) in Malta?
Offer a very short reply. -2.00e+09. In the year 1998, what is the difference between the Trade (in US$) of Gambia, The and Trade (in US$) of Malta?
Keep it short and to the point. -2.79e+09. What is the ratio of the Trade (in US$) of East Asia (developing only) in 1991 to that in 1992?
Offer a terse response. 0.88. What is the ratio of the Trade (in US$) in Malta in 1991 to that in 1992?
Offer a very short reply. 0.86. What is the ratio of the Trade (in US$) of East Asia (developing only) in 1991 to that in 1993?
Keep it short and to the point. 0.83. What is the ratio of the Trade (in US$) of Fiji in 1991 to that in 1993?
Keep it short and to the point. 0.93. What is the ratio of the Trade (in US$) in Gambia, The in 1991 to that in 1993?
Your answer should be compact. 0.95. What is the ratio of the Trade (in US$) in Malta in 1991 to that in 1993?
Make the answer very short. 0.93. What is the ratio of the Trade (in US$) of East Asia (developing only) in 1991 to that in 1994?
Your answer should be compact. 0.6. What is the ratio of the Trade (in US$) in Fiji in 1991 to that in 1994?
Make the answer very short. 0.77. What is the ratio of the Trade (in US$) of Gambia, The in 1991 to that in 1994?
Your response must be concise. 1.28. What is the ratio of the Trade (in US$) of Malta in 1991 to that in 1994?
Make the answer very short. 0.83. What is the ratio of the Trade (in US$) in East Asia (developing only) in 1991 to that in 1995?
Your answer should be compact. 0.49. What is the ratio of the Trade (in US$) of Fiji in 1991 to that in 1995?
Provide a succinct answer. 0.68. What is the ratio of the Trade (in US$) in Gambia, The in 1991 to that in 1995?
Your answer should be compact. 1.09. What is the ratio of the Trade (in US$) in Malta in 1991 to that in 1995?
Keep it short and to the point. 0.71. What is the ratio of the Trade (in US$) of East Asia (developing only) in 1991 to that in 1996?
Provide a succinct answer. 0.46. What is the ratio of the Trade (in US$) of Fiji in 1991 to that in 1996?
Offer a very short reply. 0.59. What is the ratio of the Trade (in US$) in Gambia, The in 1991 to that in 1996?
Your answer should be compact. 1.1. What is the ratio of the Trade (in US$) in Malta in 1991 to that in 1996?
Give a very brief answer. 0.75. What is the ratio of the Trade (in US$) in East Asia (developing only) in 1991 to that in 1997?
Your response must be concise. 0.42. What is the ratio of the Trade (in US$) of Fiji in 1991 to that in 1997?
Provide a succinct answer. 0.62. What is the ratio of the Trade (in US$) in Gambia, The in 1991 to that in 1997?
Offer a terse response. 1.1. What is the ratio of the Trade (in US$) of Malta in 1991 to that in 1997?
Make the answer very short. 0.77. What is the ratio of the Trade (in US$) of East Asia (developing only) in 1991 to that in 1998?
Provide a succinct answer. 0.45. What is the ratio of the Trade (in US$) in Fiji in 1991 to that in 1998?
Provide a succinct answer. 0.79. What is the ratio of the Trade (in US$) of Gambia, The in 1991 to that in 1998?
Give a very brief answer. 0.96. What is the ratio of the Trade (in US$) of Malta in 1991 to that in 1998?
Your answer should be very brief. 0.71. What is the ratio of the Trade (in US$) in East Asia (developing only) in 1992 to that in 1993?
Your answer should be compact. 0.95. What is the ratio of the Trade (in US$) of Fiji in 1992 to that in 1993?
Offer a very short reply. 0.93. What is the ratio of the Trade (in US$) in Gambia, The in 1992 to that in 1993?
Make the answer very short. 1.03. What is the ratio of the Trade (in US$) of Malta in 1992 to that in 1993?
Your answer should be compact. 1.08. What is the ratio of the Trade (in US$) of East Asia (developing only) in 1992 to that in 1994?
Make the answer very short. 0.68. What is the ratio of the Trade (in US$) of Fiji in 1992 to that in 1994?
Make the answer very short. 0.77. What is the ratio of the Trade (in US$) in Gambia, The in 1992 to that in 1994?
Provide a succinct answer. 1.38. What is the ratio of the Trade (in US$) of Malta in 1992 to that in 1994?
Offer a very short reply. 0.96. What is the ratio of the Trade (in US$) of East Asia (developing only) in 1992 to that in 1995?
Offer a very short reply. 0.56. What is the ratio of the Trade (in US$) of Fiji in 1992 to that in 1995?
Your answer should be compact. 0.68. What is the ratio of the Trade (in US$) of Gambia, The in 1992 to that in 1995?
Your response must be concise. 1.17. What is the ratio of the Trade (in US$) in Malta in 1992 to that in 1995?
Give a very brief answer. 0.83. What is the ratio of the Trade (in US$) in East Asia (developing only) in 1992 to that in 1996?
Provide a succinct answer. 0.52. What is the ratio of the Trade (in US$) of Fiji in 1992 to that in 1996?
Provide a short and direct response. 0.59. What is the ratio of the Trade (in US$) of Gambia, The in 1992 to that in 1996?
Ensure brevity in your answer.  1.18. What is the ratio of the Trade (in US$) of Malta in 1992 to that in 1996?
Your answer should be compact. 0.87. What is the ratio of the Trade (in US$) in East Asia (developing only) in 1992 to that in 1997?
Give a very brief answer. 0.47. What is the ratio of the Trade (in US$) of Fiji in 1992 to that in 1997?
Provide a succinct answer. 0.62. What is the ratio of the Trade (in US$) of Gambia, The in 1992 to that in 1997?
Provide a succinct answer. 1.19. What is the ratio of the Trade (in US$) of Malta in 1992 to that in 1997?
Your response must be concise. 0.89. What is the ratio of the Trade (in US$) of East Asia (developing only) in 1992 to that in 1998?
Keep it short and to the point. 0.51. What is the ratio of the Trade (in US$) of Fiji in 1992 to that in 1998?
Make the answer very short. 0.79. What is the ratio of the Trade (in US$) in Gambia, The in 1992 to that in 1998?
Provide a short and direct response. 1.03. What is the ratio of the Trade (in US$) in Malta in 1992 to that in 1998?
Keep it short and to the point. 0.82. What is the ratio of the Trade (in US$) in East Asia (developing only) in 1993 to that in 1994?
Give a very brief answer. 0.72. What is the ratio of the Trade (in US$) of Fiji in 1993 to that in 1994?
Provide a short and direct response. 0.83. What is the ratio of the Trade (in US$) of Gambia, The in 1993 to that in 1994?
Offer a terse response. 1.34. What is the ratio of the Trade (in US$) of Malta in 1993 to that in 1994?
Offer a terse response. 0.89. What is the ratio of the Trade (in US$) in East Asia (developing only) in 1993 to that in 1995?
Ensure brevity in your answer.  0.59. What is the ratio of the Trade (in US$) in Fiji in 1993 to that in 1995?
Provide a short and direct response. 0.73. What is the ratio of the Trade (in US$) in Gambia, The in 1993 to that in 1995?
Give a very brief answer. 1.14. What is the ratio of the Trade (in US$) in Malta in 1993 to that in 1995?
Keep it short and to the point. 0.77. What is the ratio of the Trade (in US$) of East Asia (developing only) in 1993 to that in 1996?
Provide a short and direct response. 0.55. What is the ratio of the Trade (in US$) in Fiji in 1993 to that in 1996?
Keep it short and to the point. 0.64. What is the ratio of the Trade (in US$) of Gambia, The in 1993 to that in 1996?
Your answer should be compact. 1.15. What is the ratio of the Trade (in US$) in Malta in 1993 to that in 1996?
Offer a terse response. 0.81. What is the ratio of the Trade (in US$) in East Asia (developing only) in 1993 to that in 1997?
Offer a very short reply. 0.5. What is the ratio of the Trade (in US$) of Fiji in 1993 to that in 1997?
Offer a very short reply. 0.67. What is the ratio of the Trade (in US$) of Gambia, The in 1993 to that in 1997?
Provide a succinct answer. 1.16. What is the ratio of the Trade (in US$) in Malta in 1993 to that in 1997?
Your response must be concise. 0.83. What is the ratio of the Trade (in US$) in East Asia (developing only) in 1993 to that in 1998?
Your answer should be compact. 0.54. What is the ratio of the Trade (in US$) of Fiji in 1993 to that in 1998?
Offer a very short reply. 0.85. What is the ratio of the Trade (in US$) in Gambia, The in 1993 to that in 1998?
Offer a terse response. 1. What is the ratio of the Trade (in US$) in Malta in 1993 to that in 1998?
Offer a terse response. 0.76. What is the ratio of the Trade (in US$) of East Asia (developing only) in 1994 to that in 1995?
Your answer should be very brief. 0.82. What is the ratio of the Trade (in US$) of Fiji in 1994 to that in 1995?
Your answer should be very brief. 0.88. What is the ratio of the Trade (in US$) of Gambia, The in 1994 to that in 1995?
Provide a short and direct response. 0.85. What is the ratio of the Trade (in US$) in Malta in 1994 to that in 1995?
Keep it short and to the point. 0.86. What is the ratio of the Trade (in US$) of East Asia (developing only) in 1994 to that in 1996?
Offer a terse response. 0.76. What is the ratio of the Trade (in US$) of Fiji in 1994 to that in 1996?
Offer a very short reply. 0.77. What is the ratio of the Trade (in US$) of Gambia, The in 1994 to that in 1996?
Your answer should be compact. 0.86. What is the ratio of the Trade (in US$) in Malta in 1994 to that in 1996?
Give a very brief answer. 0.91. What is the ratio of the Trade (in US$) of East Asia (developing only) in 1994 to that in 1997?
Make the answer very short. 0.69. What is the ratio of the Trade (in US$) in Fiji in 1994 to that in 1997?
Ensure brevity in your answer.  0.81. What is the ratio of the Trade (in US$) in Gambia, The in 1994 to that in 1997?
Your answer should be very brief. 0.86. What is the ratio of the Trade (in US$) of Malta in 1994 to that in 1997?
Your answer should be compact. 0.93. What is the ratio of the Trade (in US$) of East Asia (developing only) in 1994 to that in 1998?
Your answer should be compact. 0.75. What is the ratio of the Trade (in US$) of Fiji in 1994 to that in 1998?
Your response must be concise. 1.02. What is the ratio of the Trade (in US$) of Gambia, The in 1994 to that in 1998?
Give a very brief answer. 0.75. What is the ratio of the Trade (in US$) of Malta in 1994 to that in 1998?
Your response must be concise. 0.86. What is the ratio of the Trade (in US$) of East Asia (developing only) in 1995 to that in 1996?
Ensure brevity in your answer.  0.93. What is the ratio of the Trade (in US$) in Fiji in 1995 to that in 1996?
Offer a terse response. 0.87. What is the ratio of the Trade (in US$) of Gambia, The in 1995 to that in 1996?
Keep it short and to the point. 1.01. What is the ratio of the Trade (in US$) in Malta in 1995 to that in 1996?
Give a very brief answer. 1.05. What is the ratio of the Trade (in US$) of East Asia (developing only) in 1995 to that in 1997?
Provide a short and direct response. 0.85. What is the ratio of the Trade (in US$) in Fiji in 1995 to that in 1997?
Your answer should be compact. 0.91. What is the ratio of the Trade (in US$) in Gambia, The in 1995 to that in 1997?
Provide a succinct answer. 1.01. What is the ratio of the Trade (in US$) of Malta in 1995 to that in 1997?
Provide a short and direct response. 1.08. What is the ratio of the Trade (in US$) of East Asia (developing only) in 1995 to that in 1998?
Your response must be concise. 0.91. What is the ratio of the Trade (in US$) in Fiji in 1995 to that in 1998?
Offer a very short reply. 1.16. What is the ratio of the Trade (in US$) of Gambia, The in 1995 to that in 1998?
Your response must be concise. 0.88. What is the ratio of the Trade (in US$) in East Asia (developing only) in 1996 to that in 1997?
Provide a succinct answer. 0.91. What is the ratio of the Trade (in US$) of Fiji in 1996 to that in 1997?
Offer a very short reply. 1.05. What is the ratio of the Trade (in US$) in Gambia, The in 1996 to that in 1997?
Make the answer very short. 1. What is the ratio of the Trade (in US$) of Malta in 1996 to that in 1997?
Ensure brevity in your answer.  1.03. What is the ratio of the Trade (in US$) in East Asia (developing only) in 1996 to that in 1998?
Make the answer very short. 0.98. What is the ratio of the Trade (in US$) in Fiji in 1996 to that in 1998?
Give a very brief answer. 1.33. What is the ratio of the Trade (in US$) of Gambia, The in 1996 to that in 1998?
Your answer should be very brief. 0.87. What is the ratio of the Trade (in US$) of Malta in 1996 to that in 1998?
Ensure brevity in your answer.  0.95. What is the ratio of the Trade (in US$) of East Asia (developing only) in 1997 to that in 1998?
Ensure brevity in your answer.  1.08. What is the ratio of the Trade (in US$) of Fiji in 1997 to that in 1998?
Offer a very short reply. 1.27. What is the ratio of the Trade (in US$) in Gambia, The in 1997 to that in 1998?
Keep it short and to the point. 0.87. What is the ratio of the Trade (in US$) of Malta in 1997 to that in 1998?
Your response must be concise. 0.92. What is the difference between the highest and the second highest Trade (in US$) of East Asia (developing only)?
Provide a succinct answer. 3.34e+1. What is the difference between the highest and the second highest Trade (in US$) in Fiji?
Ensure brevity in your answer.  6.00e+07. What is the difference between the highest and the second highest Trade (in US$) of Gambia, The?
Ensure brevity in your answer.  5.65e+06. What is the difference between the highest and the second highest Trade (in US$) of Malta?
Ensure brevity in your answer.  1.41e+07. What is the difference between the highest and the lowest Trade (in US$) of East Asia (developing only)?
Your answer should be very brief. 2.74e+11. What is the difference between the highest and the lowest Trade (in US$) of Fiji?
Your answer should be compact. 5.45e+08. What is the difference between the highest and the lowest Trade (in US$) of Gambia, The?
Your response must be concise. 6.00e+07. What is the difference between the highest and the lowest Trade (in US$) in Malta?
Keep it short and to the point. 8.77e+08. 